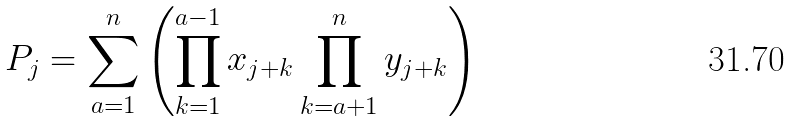<formula> <loc_0><loc_0><loc_500><loc_500>P _ { j } = \sum _ { a = 1 } ^ { n } \left ( \prod _ { k = 1 } ^ { a - 1 } x _ { j + k } \prod _ { k = a + 1 } ^ { n } y _ { j + k } \right )</formula> 